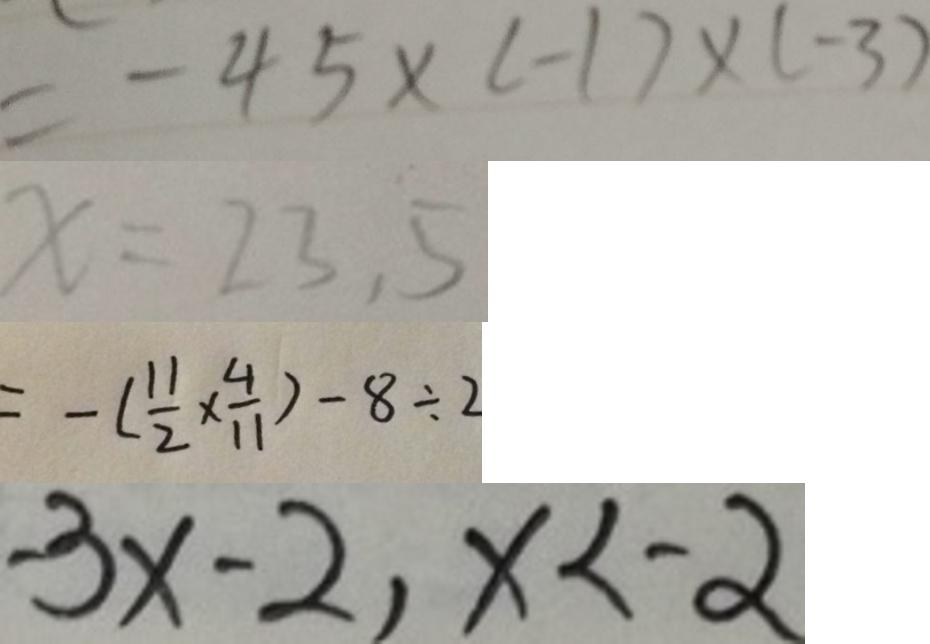<formula> <loc_0><loc_0><loc_500><loc_500>= - 4 5 \times ( - 1 ) \times ( - 3 ) 
 x = 2 3 . 5 
 = - ( \frac { 1 1 } { 2 } \times \frac { 4 } { 1 1 } ) - 8 \div 2 
 - 3 x - 2 , x < - 2</formula> 